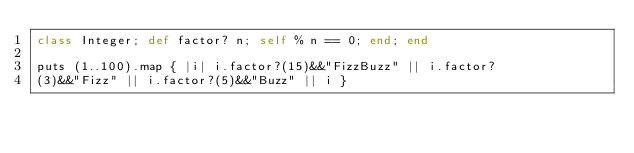Convert code to text. <code><loc_0><loc_0><loc_500><loc_500><_Ruby_>class Integer; def factor? n; self % n == 0; end; end

puts (1..100).map { |i| i.factor?(15)&&"FizzBuzz" || i.factor?
(3)&&"Fizz" || i.factor?(5)&&"Buzz" || i }
</code> 